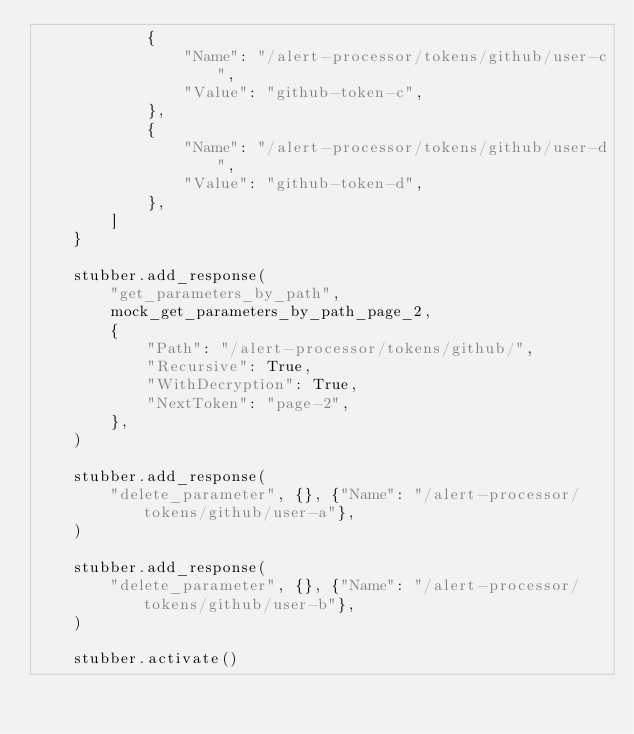Convert code to text. <code><loc_0><loc_0><loc_500><loc_500><_Python_>            {
                "Name": "/alert-processor/tokens/github/user-c",
                "Value": "github-token-c",
            },
            {
                "Name": "/alert-processor/tokens/github/user-d",
                "Value": "github-token-d",
            },
        ]
    }

    stubber.add_response(
        "get_parameters_by_path",
        mock_get_parameters_by_path_page_2,
        {
            "Path": "/alert-processor/tokens/github/",
            "Recursive": True,
            "WithDecryption": True,
            "NextToken": "page-2",
        },
    )

    stubber.add_response(
        "delete_parameter", {}, {"Name": "/alert-processor/tokens/github/user-a"},
    )

    stubber.add_response(
        "delete_parameter", {}, {"Name": "/alert-processor/tokens/github/user-b"},
    )

    stubber.activate()</code> 